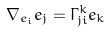Convert formula to latex. <formula><loc_0><loc_0><loc_500><loc_500>\nabla _ { e _ { i } } e _ { j } = \Gamma _ { j i } ^ { k } e _ { k }</formula> 